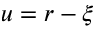Convert formula to latex. <formula><loc_0><loc_0><loc_500><loc_500>u = r - \xi</formula> 